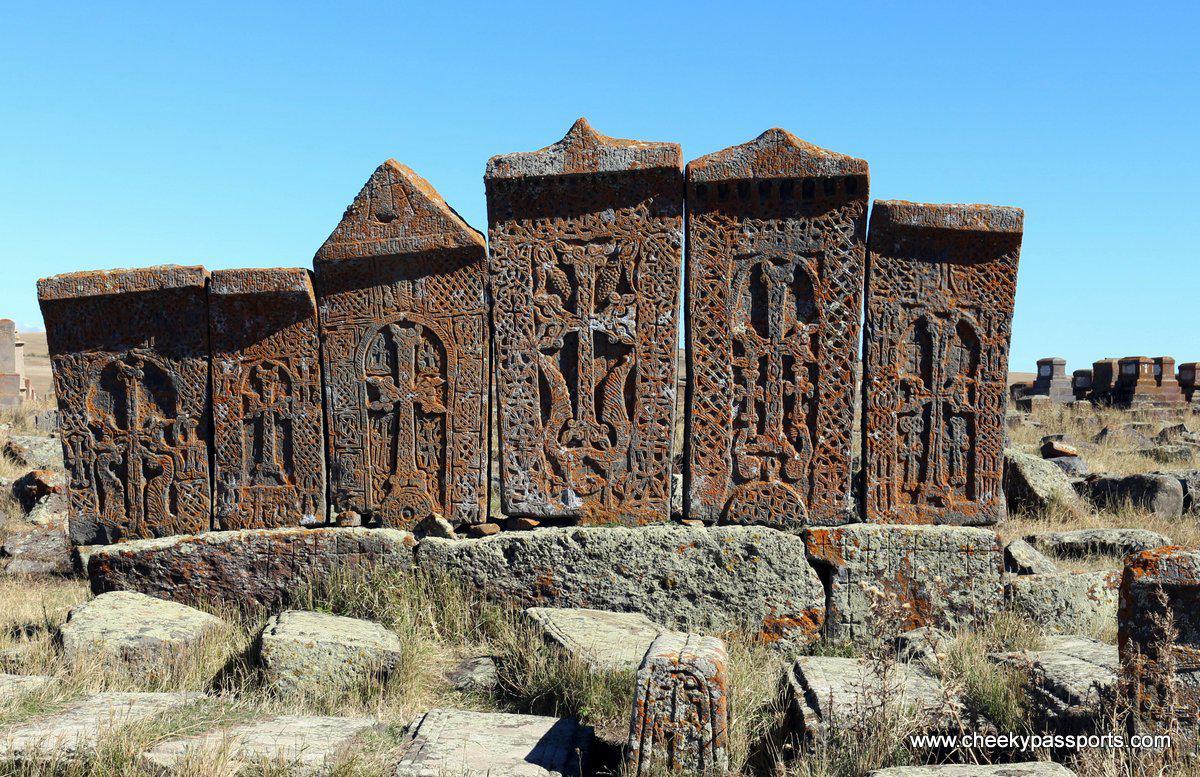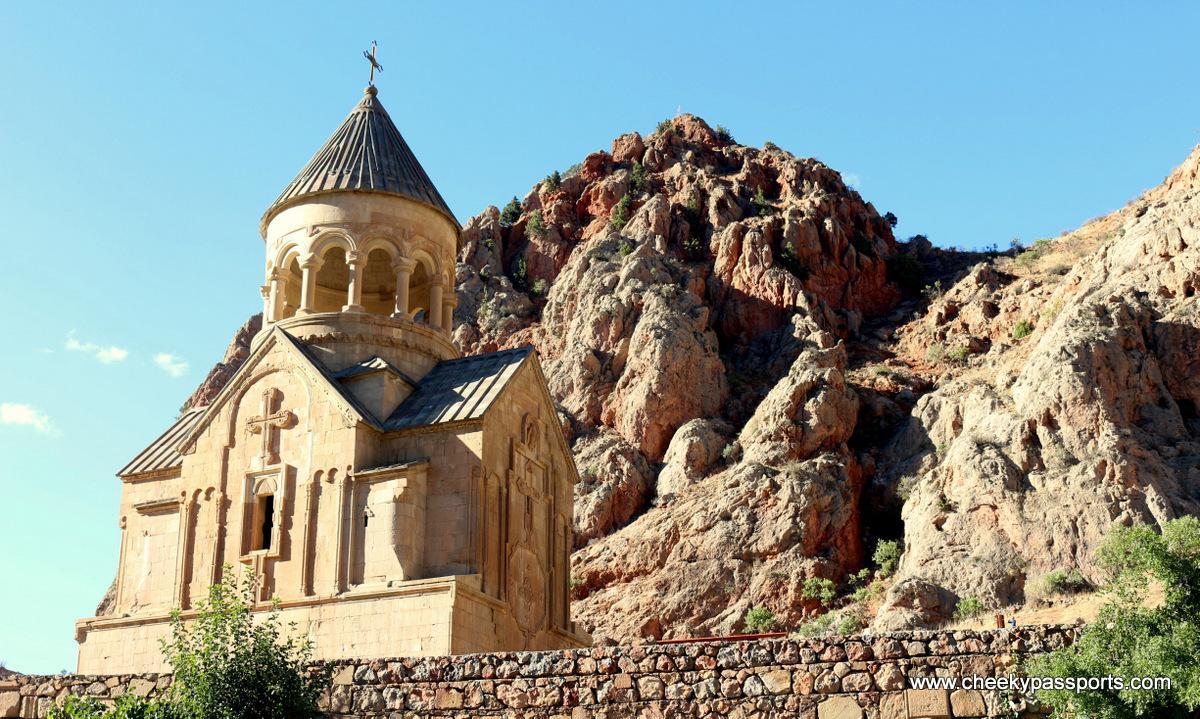The first image is the image on the left, the second image is the image on the right. For the images displayed, is the sentence "The right image shows a beige building with a cone-shaped roof topped with a cross above a cylindrical tower." factually correct? Answer yes or no. Yes. 